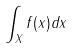<formula> <loc_0><loc_0><loc_500><loc_500>\int _ { X } f ( x ) d x</formula> 